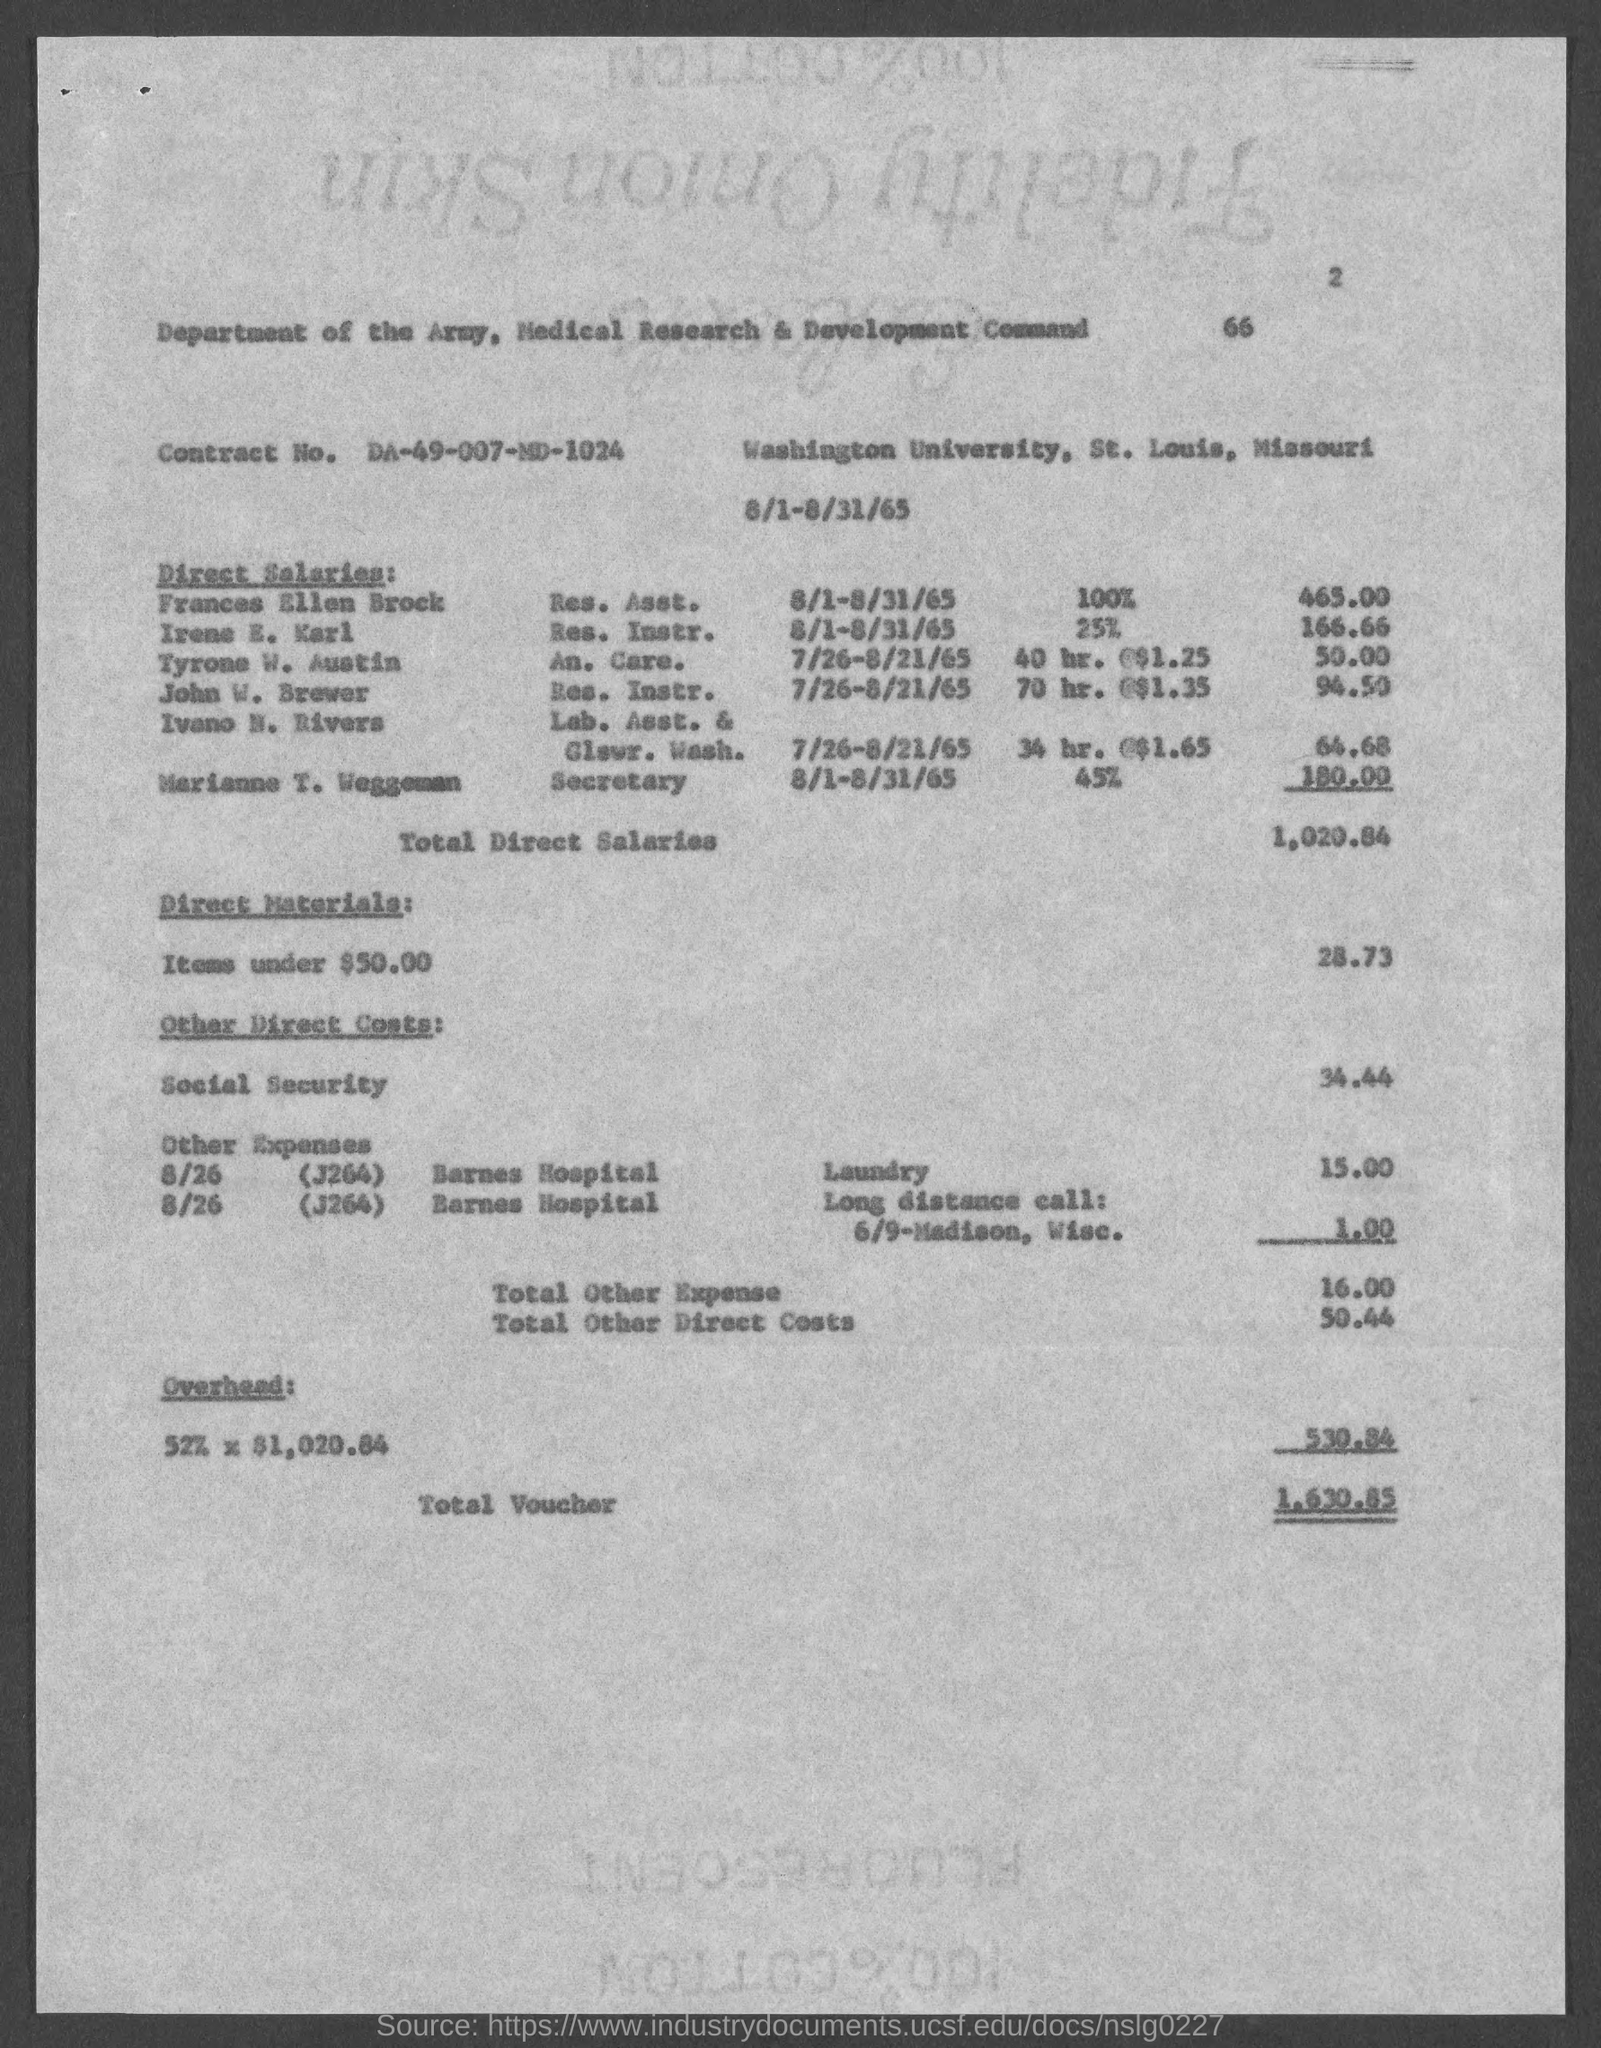What is Contract No.?
Make the answer very short. DA-49-007-MD-1024. What is the Total Direct Salaries?
Provide a short and direct response. 1,020.84. What is the Total Voucher?
Offer a terse response. 1,630.85. 